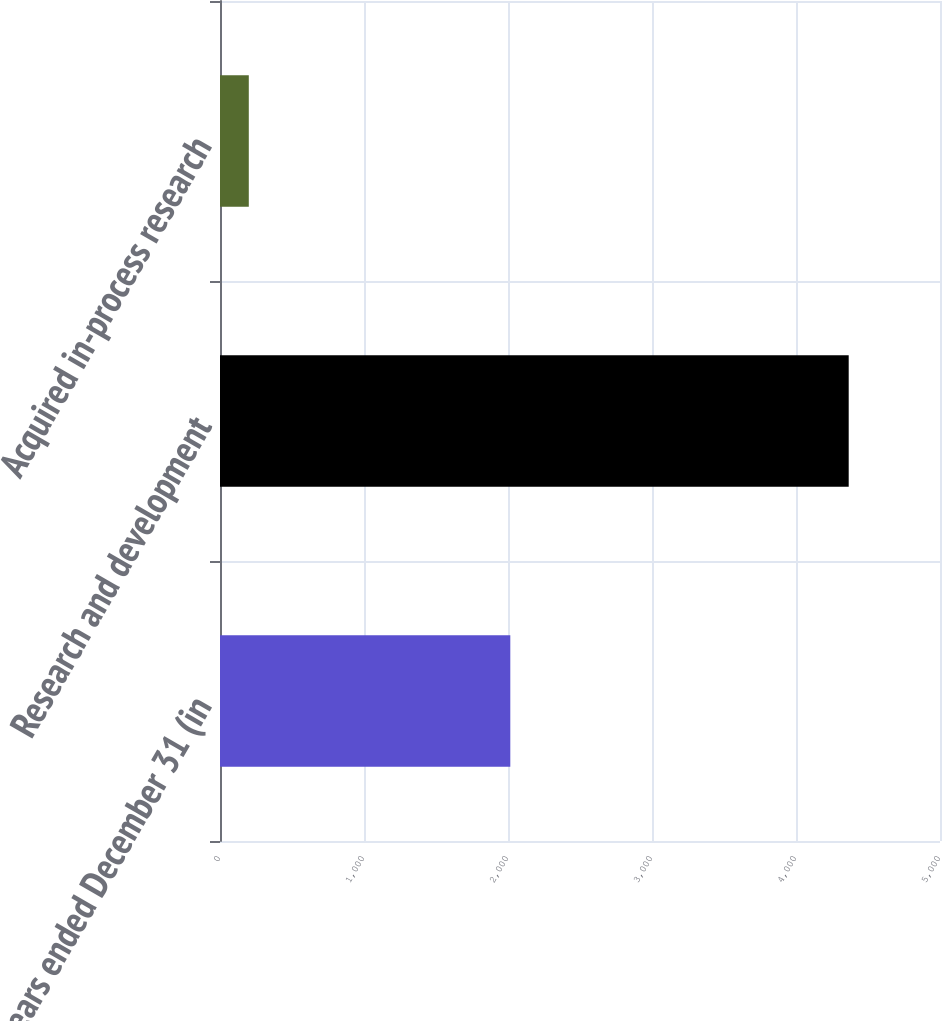Convert chart. <chart><loc_0><loc_0><loc_500><loc_500><bar_chart><fcel>years ended December 31 (in<fcel>Research and development<fcel>Acquired in-process research<nl><fcel>2016<fcel>4366<fcel>200<nl></chart> 